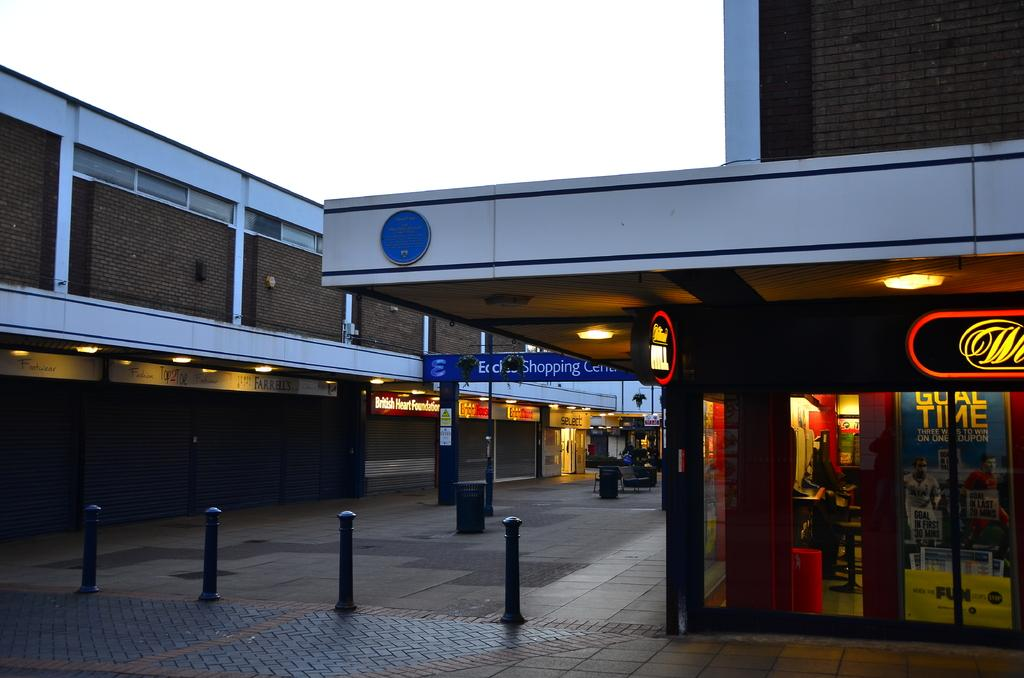<image>
Present a compact description of the photo's key features. One of the businesses in this center is the British Heart Foundation. 